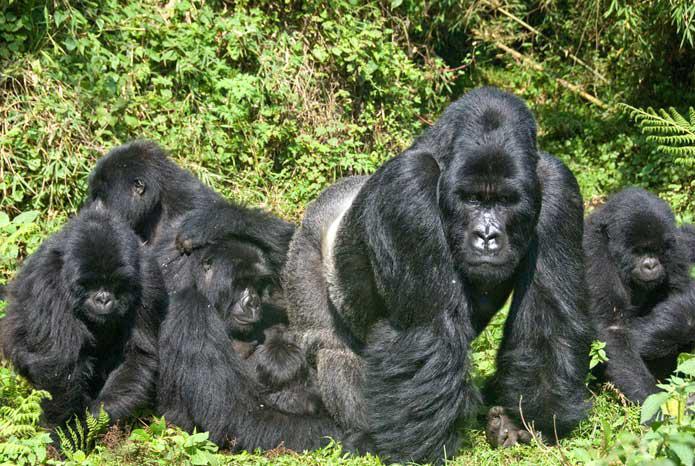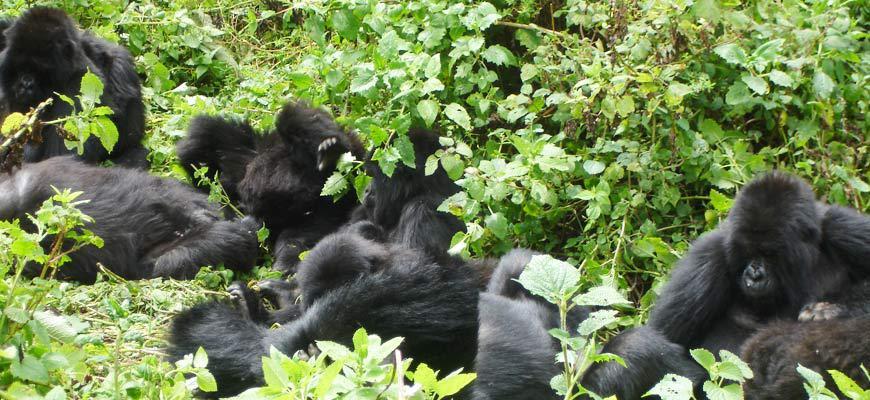The first image is the image on the left, the second image is the image on the right. Considering the images on both sides, is "There's no more than four gorillas in the right image." valid? Answer yes or no. No. The first image is the image on the left, the second image is the image on the right. Assess this claim about the two images: "There are six gorillas in the image pair.". Correct or not? Answer yes or no. No. 